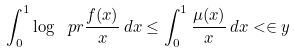Convert formula to latex. <formula><loc_0><loc_0><loc_500><loc_500>\int _ { 0 } ^ { 1 } \log \ p r { \frac { f ( x ) } { x } } \, d x \leq \int _ { 0 } ^ { 1 } \frac { \mu ( x ) } { x } \, d x < \in y</formula> 